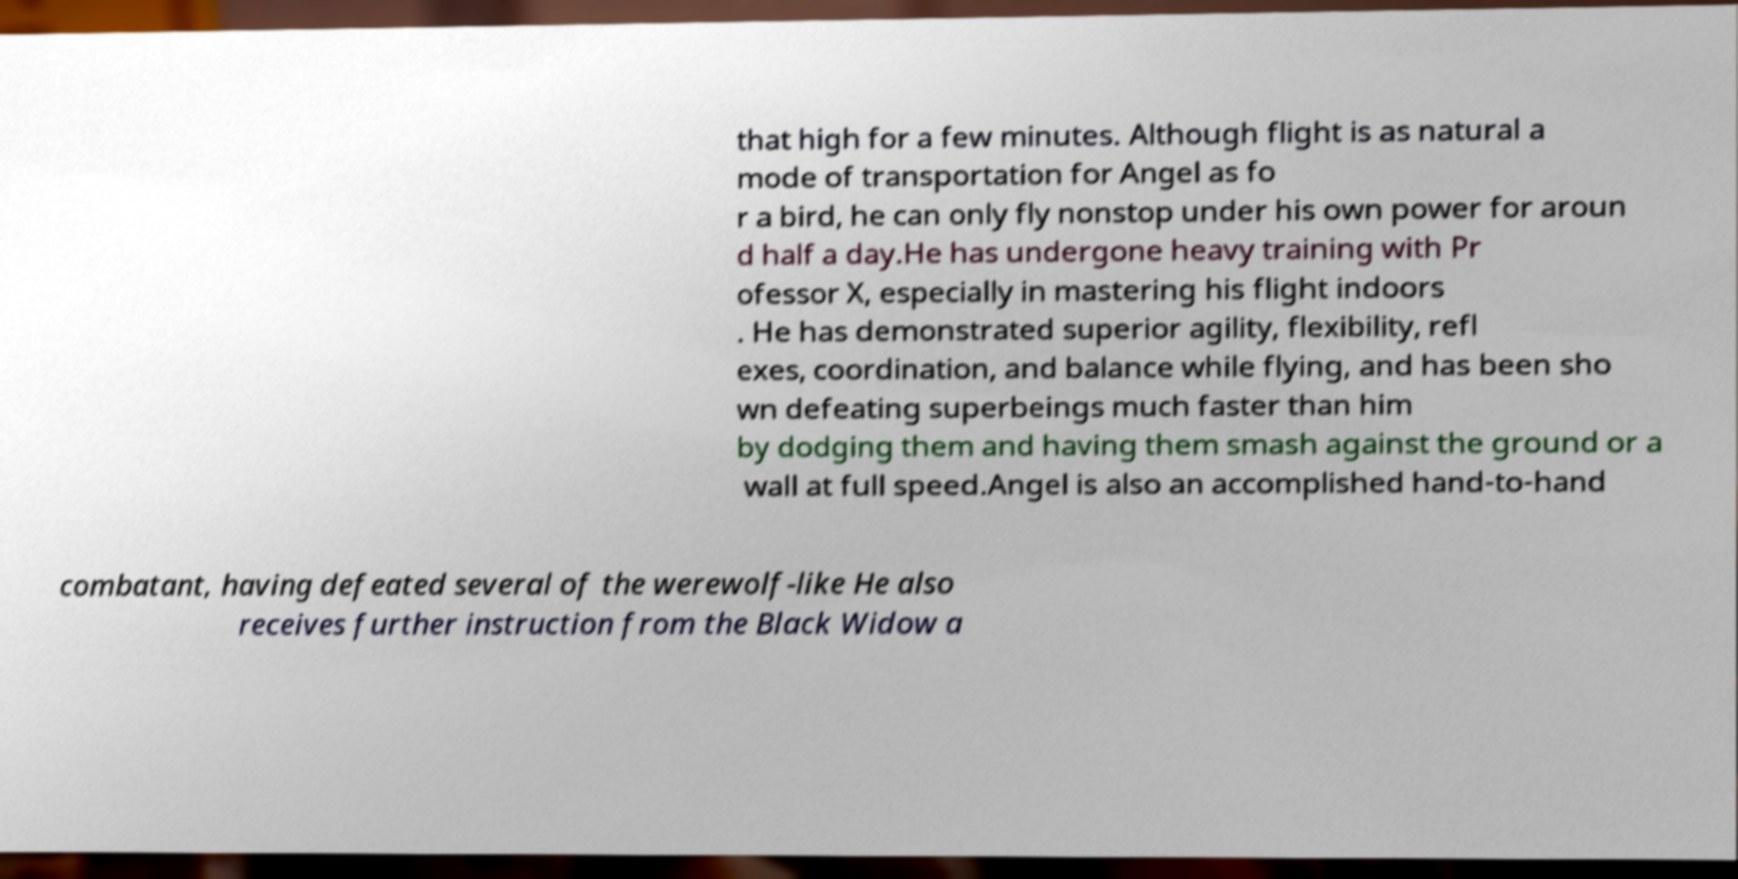Could you extract and type out the text from this image? that high for a few minutes. Although flight is as natural a mode of transportation for Angel as fo r a bird, he can only fly nonstop under his own power for aroun d half a day.He has undergone heavy training with Pr ofessor X, especially in mastering his flight indoors . He has demonstrated superior agility, flexibility, refl exes, coordination, and balance while flying, and has been sho wn defeating superbeings much faster than him by dodging them and having them smash against the ground or a wall at full speed.Angel is also an accomplished hand-to-hand combatant, having defeated several of the werewolf-like He also receives further instruction from the Black Widow a 